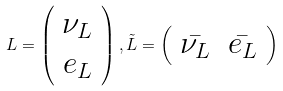<formula> <loc_0><loc_0><loc_500><loc_500>L = \left ( \begin{array} { c } \nu _ { L } \\ e _ { L } \end{array} \right ) , \tilde { L } = \left ( \begin{array} { c c } \bar { \nu _ { L } } & \bar { e _ { L } } \end{array} \right )</formula> 